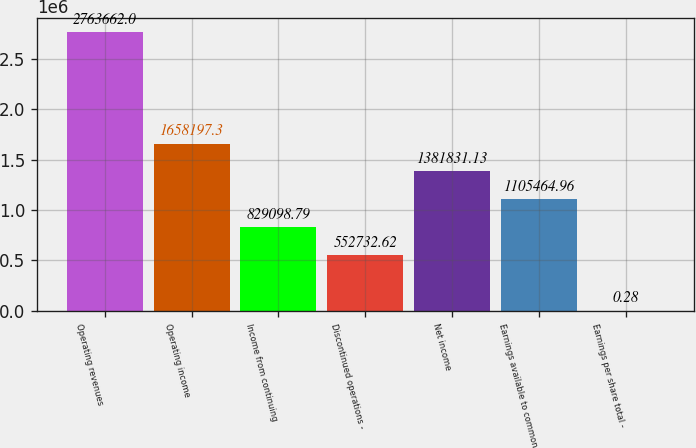Convert chart. <chart><loc_0><loc_0><loc_500><loc_500><bar_chart><fcel>Operating revenues<fcel>Operating income<fcel>Income from continuing<fcel>Discontinued operations -<fcel>Net income<fcel>Earnings available to common<fcel>Earnings per share total -<nl><fcel>2.76366e+06<fcel>1.6582e+06<fcel>829099<fcel>552733<fcel>1.38183e+06<fcel>1.10546e+06<fcel>0.28<nl></chart> 